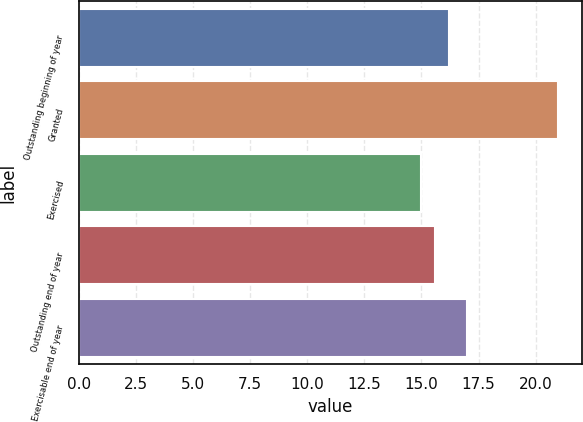Convert chart. <chart><loc_0><loc_0><loc_500><loc_500><bar_chart><fcel>Outstanding beginning of year<fcel>Granted<fcel>Exercised<fcel>Outstanding end of year<fcel>Exercisable end of year<nl><fcel>16.2<fcel>21<fcel>15<fcel>15.6<fcel>17<nl></chart> 